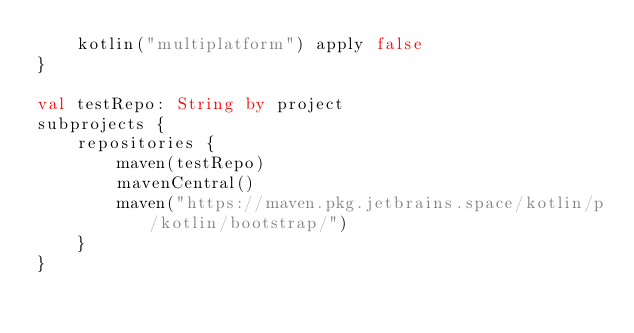Convert code to text. <code><loc_0><loc_0><loc_500><loc_500><_Kotlin_>    kotlin("multiplatform") apply false
}

val testRepo: String by project
subprojects {
    repositories {
        maven(testRepo)
        mavenCentral()
        maven("https://maven.pkg.jetbrains.space/kotlin/p/kotlin/bootstrap/")
    }
}
</code> 